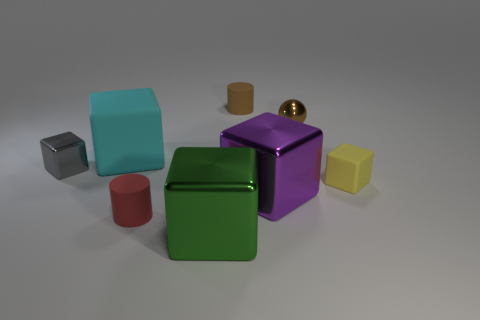What number of small objects are either red cylinders or brown cylinders?
Keep it short and to the point. 2. Are there any other things of the same color as the big matte object?
Keep it short and to the point. No. What is the size of the metal object that is both in front of the small brown metal thing and to the right of the big green object?
Your response must be concise. Large. There is a tiny metal sphere to the right of the big cyan cube; is it the same color as the cylinder that is behind the gray block?
Give a very brief answer. Yes. What number of other things are there of the same material as the red cylinder
Make the answer very short. 3. There is a shiny thing that is in front of the tiny yellow thing and behind the tiny red cylinder; what is its shape?
Keep it short and to the point. Cube. Is the color of the small metal ball the same as the small matte thing that is behind the large cyan matte object?
Provide a succinct answer. Yes. Does the rubber cube that is to the right of the green cube have the same size as the brown sphere?
Your answer should be very brief. Yes. What is the material of the purple object that is the same shape as the tiny gray metallic object?
Your answer should be compact. Metal. Is the shape of the brown shiny thing the same as the tiny red object?
Offer a very short reply. No. 